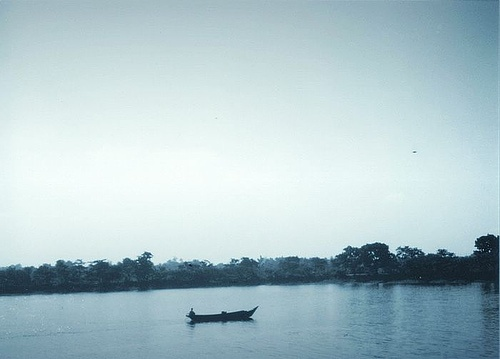Describe the objects in this image and their specific colors. I can see boat in lightblue, darkblue, navy, blue, and teal tones and people in lightblue, darkblue, blue, teal, and navy tones in this image. 